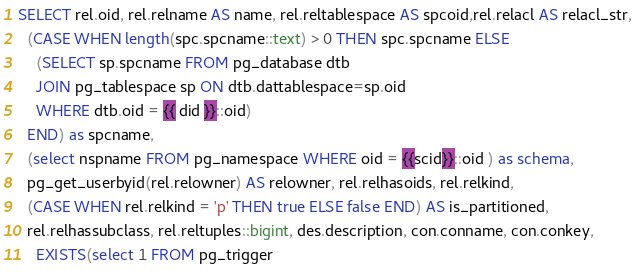<code> <loc_0><loc_0><loc_500><loc_500><_SQL_>SELECT rel.oid, rel.relname AS name, rel.reltablespace AS spcoid,rel.relacl AS relacl_str,
  (CASE WHEN length(spc.spcname::text) > 0 THEN spc.spcname ELSE
    (SELECT sp.spcname FROM pg_database dtb
    JOIN pg_tablespace sp ON dtb.dattablespace=sp.oid
    WHERE dtb.oid = {{ did }}::oid)
  END) as spcname,
  (select nspname FROM pg_namespace WHERE oid = {{scid}}::oid ) as schema,
  pg_get_userbyid(rel.relowner) AS relowner, rel.relhasoids, rel.relkind,
  (CASE WHEN rel.relkind = 'p' THEN true ELSE false END) AS is_partitioned,
  rel.relhassubclass, rel.reltuples::bigint, des.description, con.conname, con.conkey,
	EXISTS(select 1 FROM pg_trigger</code> 